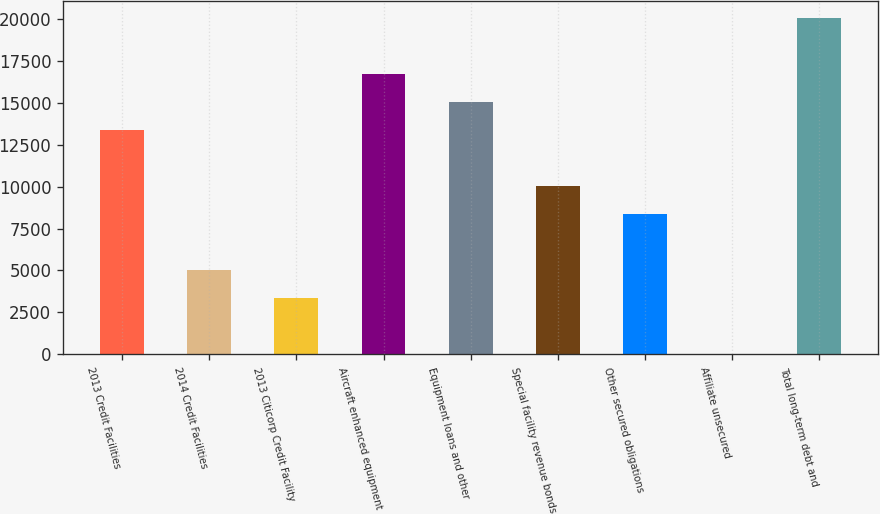Convert chart to OTSL. <chart><loc_0><loc_0><loc_500><loc_500><bar_chart><fcel>2013 Credit Facilities<fcel>2014 Credit Facilities<fcel>2013 Citicorp Credit Facility<fcel>Aircraft enhanced equipment<fcel>Equipment loans and other<fcel>Special facility revenue bonds<fcel>Other secured obligations<fcel>Affiliate unsecured<fcel>Total long-term debt and<nl><fcel>13373.4<fcel>5031.9<fcel>3363.6<fcel>16710<fcel>15041.7<fcel>10036.8<fcel>8368.5<fcel>27<fcel>20046.6<nl></chart> 